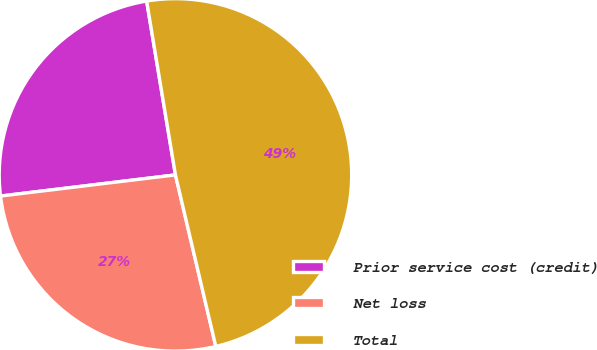Convert chart to OTSL. <chart><loc_0><loc_0><loc_500><loc_500><pie_chart><fcel>Prior service cost (credit)<fcel>Net loss<fcel>Total<nl><fcel>24.3%<fcel>26.76%<fcel>48.93%<nl></chart> 